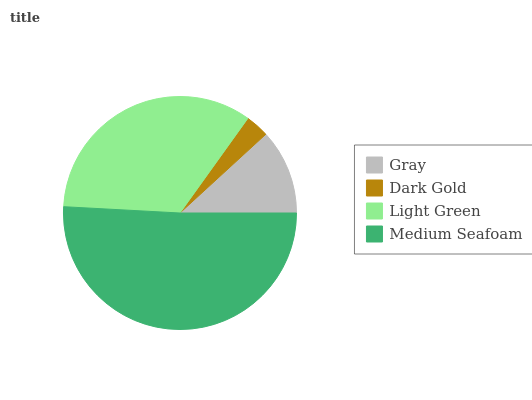Is Dark Gold the minimum?
Answer yes or no. Yes. Is Medium Seafoam the maximum?
Answer yes or no. Yes. Is Light Green the minimum?
Answer yes or no. No. Is Light Green the maximum?
Answer yes or no. No. Is Light Green greater than Dark Gold?
Answer yes or no. Yes. Is Dark Gold less than Light Green?
Answer yes or no. Yes. Is Dark Gold greater than Light Green?
Answer yes or no. No. Is Light Green less than Dark Gold?
Answer yes or no. No. Is Light Green the high median?
Answer yes or no. Yes. Is Gray the low median?
Answer yes or no. Yes. Is Medium Seafoam the high median?
Answer yes or no. No. Is Dark Gold the low median?
Answer yes or no. No. 